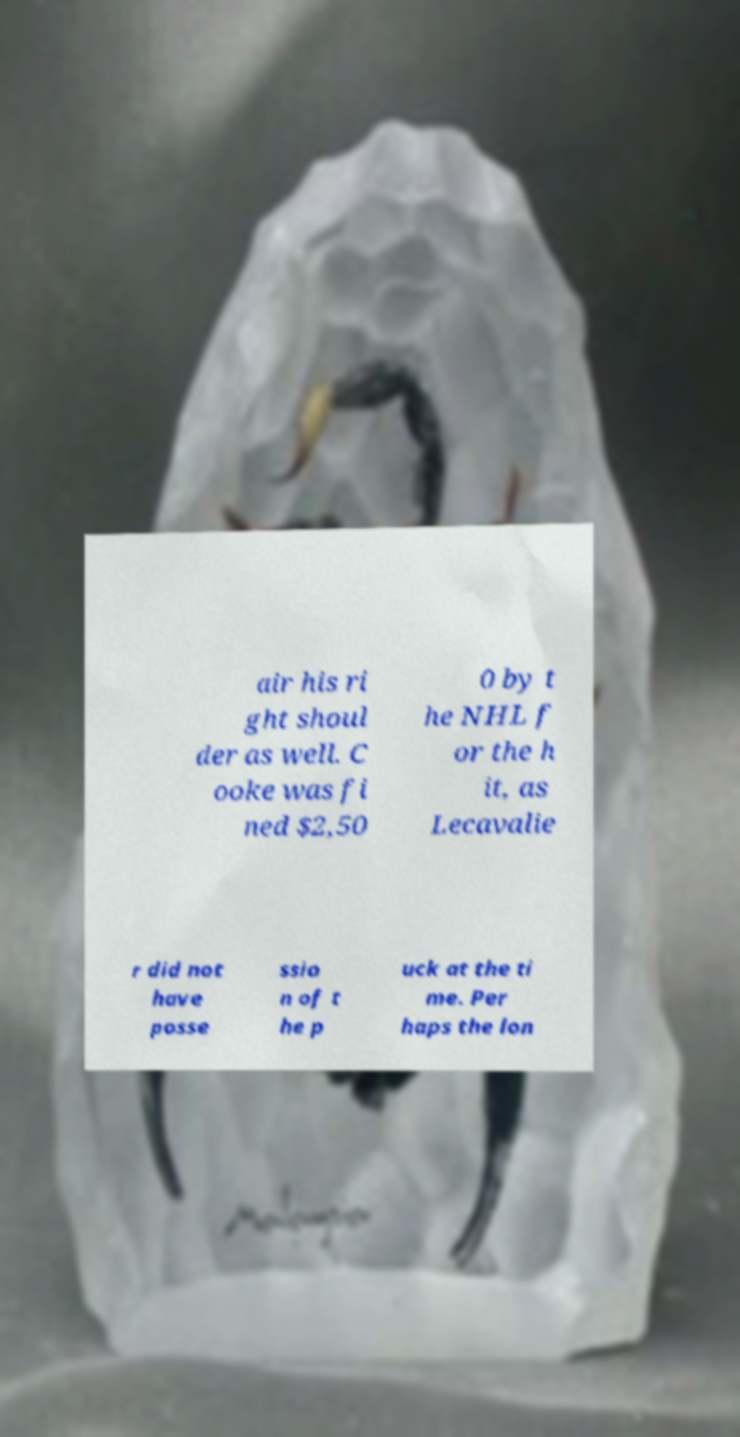For documentation purposes, I need the text within this image transcribed. Could you provide that? air his ri ght shoul der as well. C ooke was fi ned $2,50 0 by t he NHL f or the h it, as Lecavalie r did not have posse ssio n of t he p uck at the ti me. Per haps the lon 